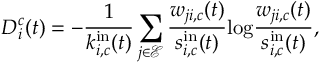<formula> <loc_0><loc_0><loc_500><loc_500>D _ { i } ^ { c } ( t ) = - \frac { 1 } { k _ { i , c } ^ { i n } ( t ) } \sum _ { j \in { \ m a t h s c r { E } } } \frac { w _ { j i , c } ( t ) } { s _ { i , c } ^ { i n } ( t ) } \log \frac { w _ { j i , c } ( t ) } { s _ { i , c } ^ { i n } ( t ) } ,</formula> 